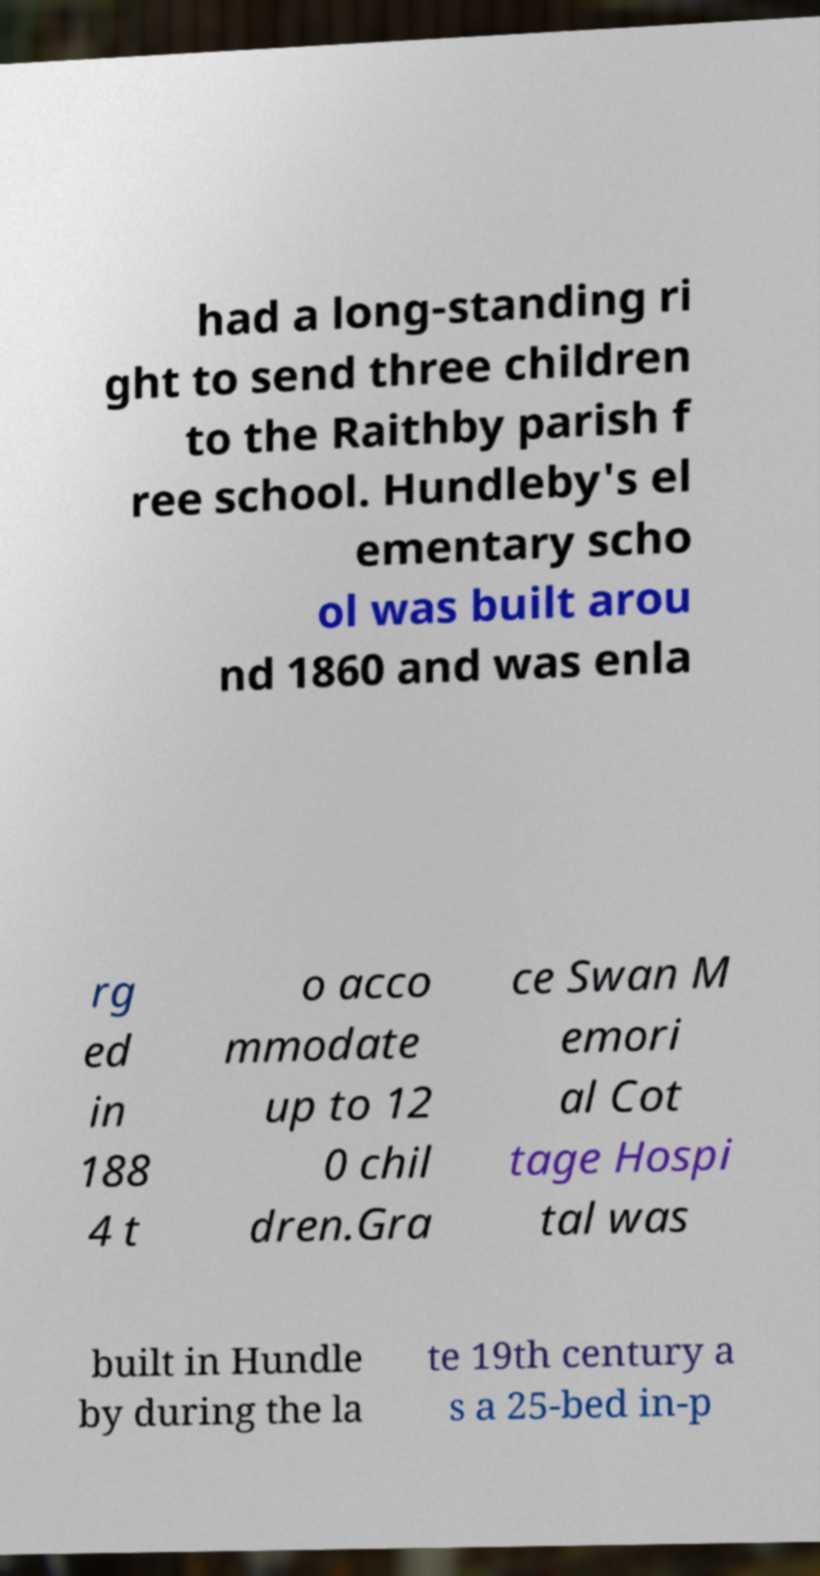Please identify and transcribe the text found in this image. had a long-standing ri ght to send three children to the Raithby parish f ree school. Hundleby's el ementary scho ol was built arou nd 1860 and was enla rg ed in 188 4 t o acco mmodate up to 12 0 chil dren.Gra ce Swan M emori al Cot tage Hospi tal was built in Hundle by during the la te 19th century a s a 25-bed in-p 